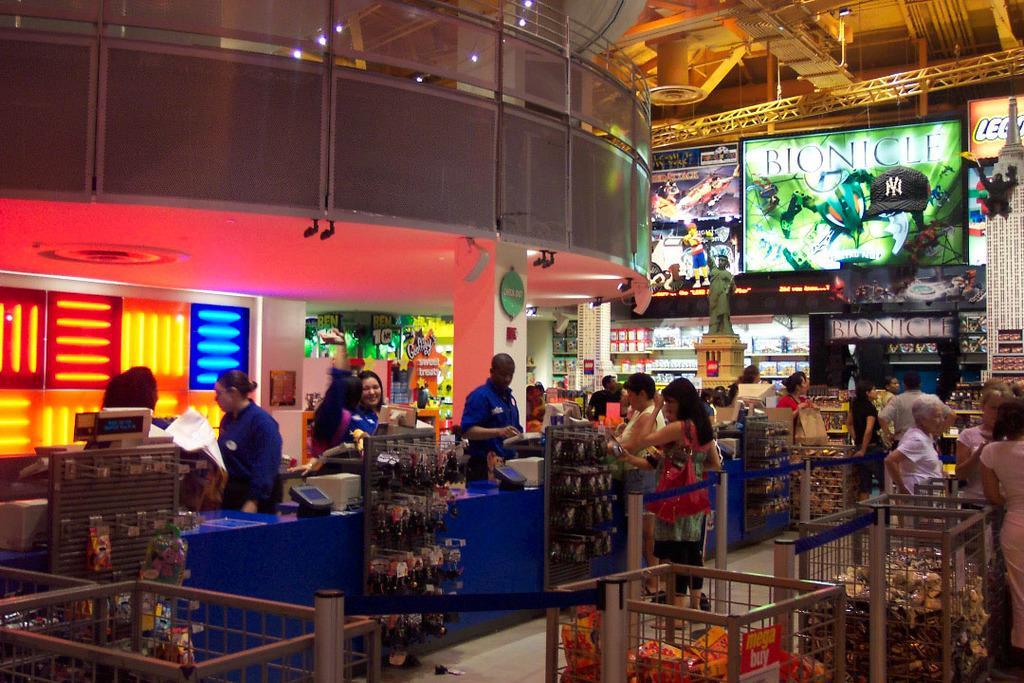In one or two sentences, can you explain what this image depicts? In this image we can see a store. In the store there are people standing on the floor, objects arranged in the baskets and hanged to the hooks, desktops, electric lights, iron grills and display screens. 